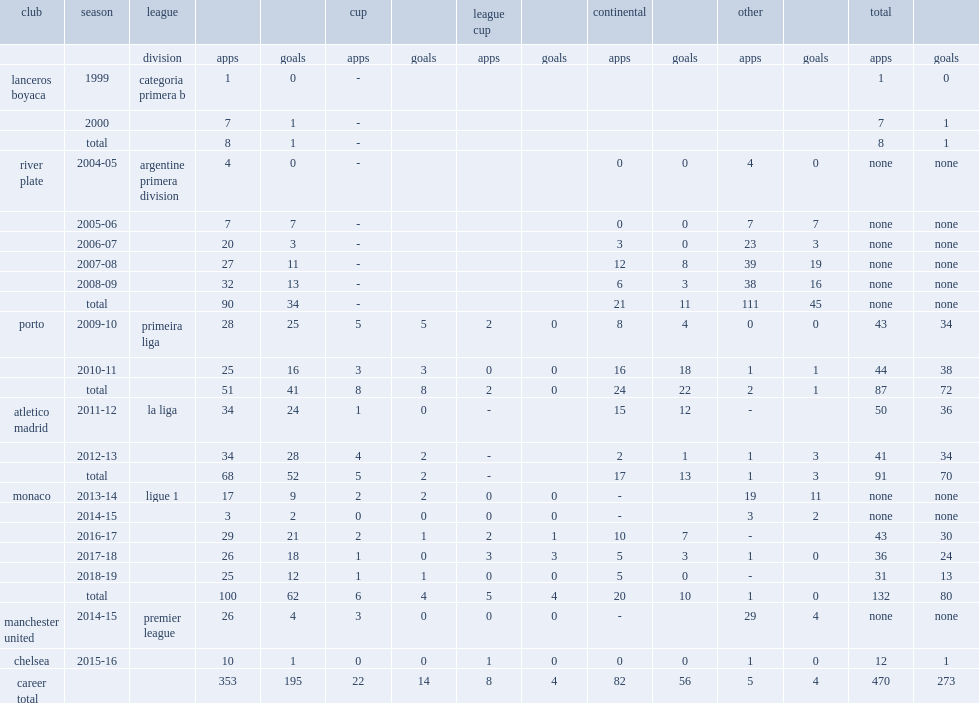Which league did falcao make his debut for lanceros boyaca in 1999? Categoria primera b. 